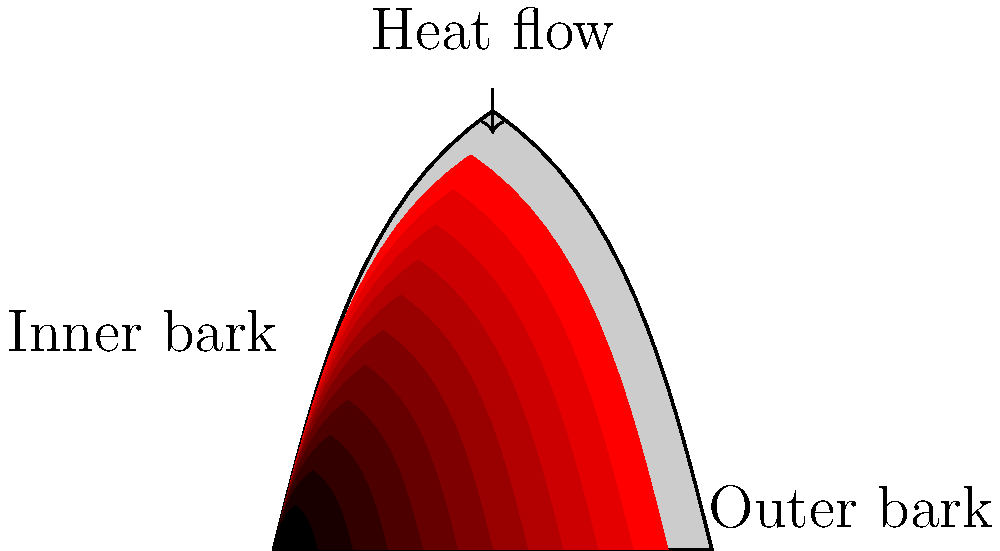In the cross-section of a fire-resistant Australian eucalyptus bark shown above, which region is likely to have the highest temperature during a bushfire, and why does this temperature distribution pattern contribute to the tree's survival? To answer this question, let's analyze the heat distribution in the eucalyptus bark cross-section:

1. Observe the color gradient: The diagram shows a color gradient from red (outer bark) to white (inner bark), indicating a temperature gradient.

2. Identify the hottest region: The outer bark (labeled) is colored deep red, indicating the highest temperature.

3. Understand heat transfer: Heat flows from high to low temperature regions. In this case, from the outer bark towards the inner bark.

4. Analyze the bark structure: Eucalyptus bark is thick and layered, acting as insulation.

5. Consider the insulation effect: The thick bark slows down heat transfer, creating a temperature gradient.

6. Relate to fire resistance: This gradual temperature change protects the tree's vital inner tissues from extreme heat.

7. Survival mechanism: By maintaining a cooler inner bark, the tree's cambium (growth layer) is protected, allowing the tree to survive and recover after a fire.

The temperature distribution pattern, with the highest temperature at the outer bark and a gradual decrease towards the inner bark, is crucial for the eucalyptus tree's fire resistance and survival during bushfires.
Answer: Outer bark; gradual temperature decrease protects inner tissues. 